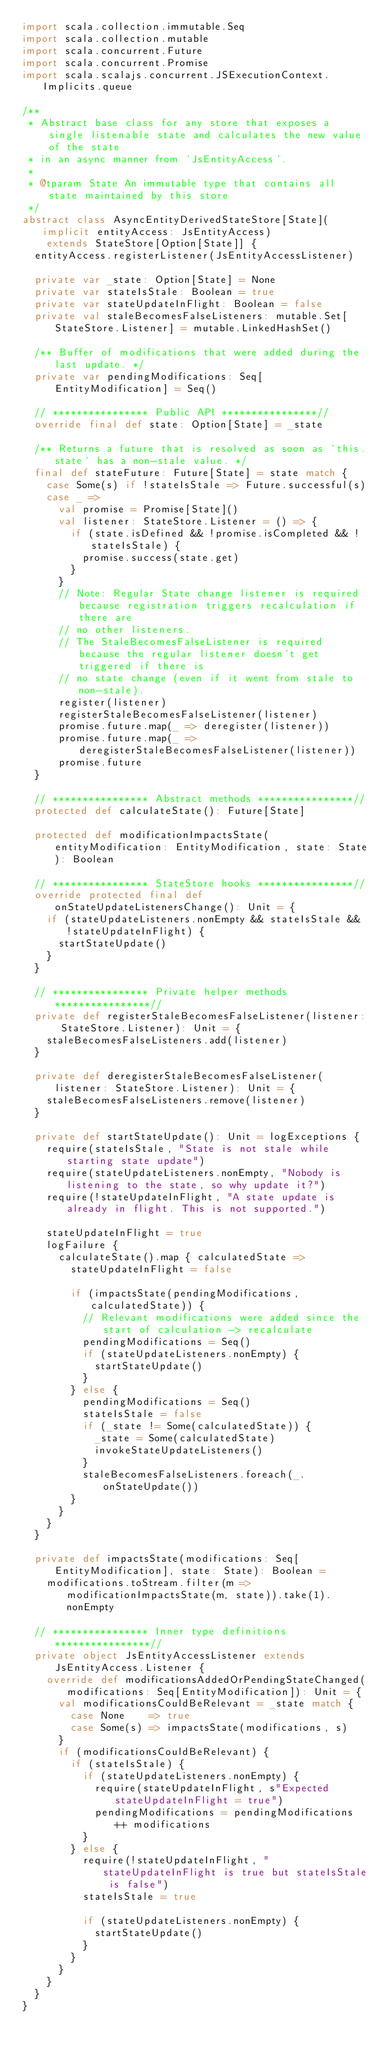Convert code to text. <code><loc_0><loc_0><loc_500><loc_500><_Scala_>import scala.collection.immutable.Seq
import scala.collection.mutable
import scala.concurrent.Future
import scala.concurrent.Promise
import scala.scalajs.concurrent.JSExecutionContext.Implicits.queue

/**
 * Abstract base class for any store that exposes a single listenable state and calculates the new value of the state
 * in an async manner from `JsEntityAccess`.
 *
 * @tparam State An immutable type that contains all state maintained by this store
 */
abstract class AsyncEntityDerivedStateStore[State](implicit entityAccess: JsEntityAccess)
    extends StateStore[Option[State]] {
  entityAccess.registerListener(JsEntityAccessListener)

  private var _state: Option[State] = None
  private var stateIsStale: Boolean = true
  private var stateUpdateInFlight: Boolean = false
  private val staleBecomesFalseListeners: mutable.Set[StateStore.Listener] = mutable.LinkedHashSet()

  /** Buffer of modifications that were added during the last update. */
  private var pendingModifications: Seq[EntityModification] = Seq()

  // **************** Public API ****************//
  override final def state: Option[State] = _state

  /** Returns a future that is resolved as soon as `this.state` has a non-stale value. */
  final def stateFuture: Future[State] = state match {
    case Some(s) if !stateIsStale => Future.successful(s)
    case _ =>
      val promise = Promise[State]()
      val listener: StateStore.Listener = () => {
        if (state.isDefined && !promise.isCompleted && !stateIsStale) {
          promise.success(state.get)
        }
      }
      // Note: Regular State change listener is required because registration triggers recalculation if there are
      // no other listeners.
      // The StaleBecomesFalseListener is required because the regular listener doesn't get triggered if there is
      // no state change (even if it went from stale to non-stale).
      register(listener)
      registerStaleBecomesFalseListener(listener)
      promise.future.map(_ => deregister(listener))
      promise.future.map(_ => deregisterStaleBecomesFalseListener(listener))
      promise.future
  }

  // **************** Abstract methods ****************//
  protected def calculateState(): Future[State]

  protected def modificationImpactsState(entityModification: EntityModification, state: State): Boolean

  // **************** StateStore hooks ****************//
  override protected final def onStateUpdateListenersChange(): Unit = {
    if (stateUpdateListeners.nonEmpty && stateIsStale && !stateUpdateInFlight) {
      startStateUpdate()
    }
  }

  // **************** Private helper methods ****************//
  private def registerStaleBecomesFalseListener(listener: StateStore.Listener): Unit = {
    staleBecomesFalseListeners.add(listener)
  }

  private def deregisterStaleBecomesFalseListener(listener: StateStore.Listener): Unit = {
    staleBecomesFalseListeners.remove(listener)
  }

  private def startStateUpdate(): Unit = logExceptions {
    require(stateIsStale, "State is not stale while starting state update")
    require(stateUpdateListeners.nonEmpty, "Nobody is listening to the state, so why update it?")
    require(!stateUpdateInFlight, "A state update is already in flight. This is not supported.")

    stateUpdateInFlight = true
    logFailure {
      calculateState().map { calculatedState =>
        stateUpdateInFlight = false

        if (impactsState(pendingModifications, calculatedState)) {
          // Relevant modifications were added since the start of calculation -> recalculate
          pendingModifications = Seq()
          if (stateUpdateListeners.nonEmpty) {
            startStateUpdate()
          }
        } else {
          pendingModifications = Seq()
          stateIsStale = false
          if (_state != Some(calculatedState)) {
            _state = Some(calculatedState)
            invokeStateUpdateListeners()
          }
          staleBecomesFalseListeners.foreach(_.onStateUpdate())
        }
      }
    }
  }

  private def impactsState(modifications: Seq[EntityModification], state: State): Boolean =
    modifications.toStream.filter(m => modificationImpactsState(m, state)).take(1).nonEmpty

  // **************** Inner type definitions ****************//
  private object JsEntityAccessListener extends JsEntityAccess.Listener {
    override def modificationsAddedOrPendingStateChanged(modifications: Seq[EntityModification]): Unit = {
      val modificationsCouldBeRelevant = _state match {
        case None    => true
        case Some(s) => impactsState(modifications, s)
      }
      if (modificationsCouldBeRelevant) {
        if (stateIsStale) {
          if (stateUpdateListeners.nonEmpty) {
            require(stateUpdateInFlight, s"Expected stateUpdateInFlight = true")
            pendingModifications = pendingModifications ++ modifications
          }
        } else {
          require(!stateUpdateInFlight, "stateUpdateInFlight is true but stateIsStale is false")
          stateIsStale = true

          if (stateUpdateListeners.nonEmpty) {
            startStateUpdate()
          }
        }
      }
    }
  }
}
</code> 